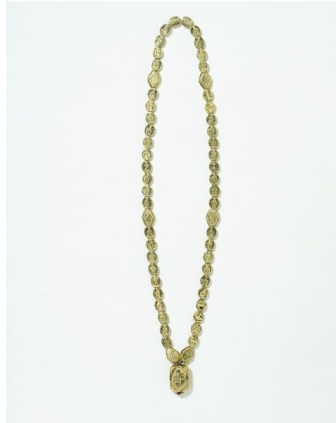Invent a fantastical story involving the necklace. In a realm where magic and reality intertwine, the Golden Bloom Necklace was forged by celestial beings. It was said to possess the power to bring life to desolate lands. Only those with pure hearts could wear it, for upon touching impure hearts, the necklace would turn to ash. The pendant was imbued with a seed from the Tree of Eternity, and when worn, it had the power to heal wounds and foster peace. For centuries, it lay dormant until an unsuspecting farmer discovered it while tilling the land. Upon wearing it, she was chosen as the Guardian of Sprouts, destined to revitalize the barren kingdom. Each step she took turned the ground green, and floral blooms trailed behind her wherever she wandered. The farmer, with her newfound powers, brought an era of prosperity, and the necklace became a symbol of hope, revered by all who witnessed its magic. And so, the Golden Bloom Necklace passed into legend, its story retold as a reminder that even the most humble beginnings can lead to extraordinary destinies. Discuss the real-world design techniques that could be used to create this necklace. To create a necklace of this caliber, a combination of traditional and modern jewelry-making techniques would likely be utilized. Initially, a detailed design would be sketched by a jewelry designer, planning the layout of the beads and the intricacy of the pendant. Skilled artisans would then cast the beads and the pendant in gold, using techniques like lost wax casting to achieve fine detail. Each bead would be meticulously polished to achieve a uniform shine. The floral design on the pendant would be crafted through delicate engraving, requiring precision tools and a steady hand. Depending on the methods employed, the pendant might also be etched using laser technology for a more precise finish. Afterward, the beads would be strung together on a durable but flexible cord, often made from precious metal wire or a high-quality synthetic thread, ensuring both flexibility and resilience. Finally, the necklace would undergo quality checks to confirm its durability and finish before being packaged and presented for sale. 